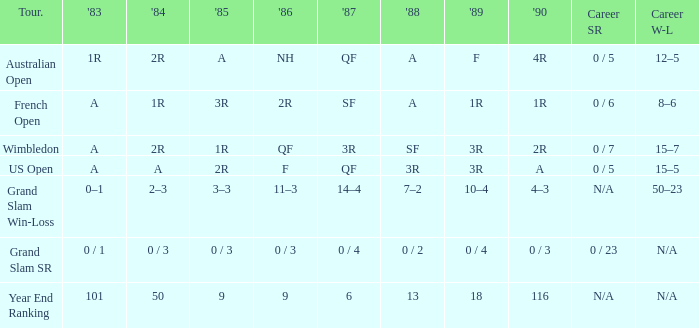What happened in 1985 when the career win-loss was not provided and the career sr was 0 out of 23? 0 / 3. Could you parse the entire table as a dict? {'header': ['Tour.', "'83", "'84", "'85", "'86", "'87", "'88", "'89", "'90", 'Career SR', 'Career W-L'], 'rows': [['Australian Open', '1R', '2R', 'A', 'NH', 'QF', 'A', 'F', '4R', '0 / 5', '12–5'], ['French Open', 'A', '1R', '3R', '2R', 'SF', 'A', '1R', '1R', '0 / 6', '8–6'], ['Wimbledon', 'A', '2R', '1R', 'QF', '3R', 'SF', '3R', '2R', '0 / 7', '15–7'], ['US Open', 'A', 'A', '2R', 'F', 'QF', '3R', '3R', 'A', '0 / 5', '15–5'], ['Grand Slam Win-Loss', '0–1', '2–3', '3–3', '11–3', '14–4', '7–2', '10–4', '4–3', 'N/A', '50–23'], ['Grand Slam SR', '0 / 1', '0 / 3', '0 / 3', '0 / 3', '0 / 4', '0 / 2', '0 / 4', '0 / 3', '0 / 23', 'N/A'], ['Year End Ranking', '101', '50', '9', '9', '6', '13', '18', '116', 'N/A', 'N/A']]} 